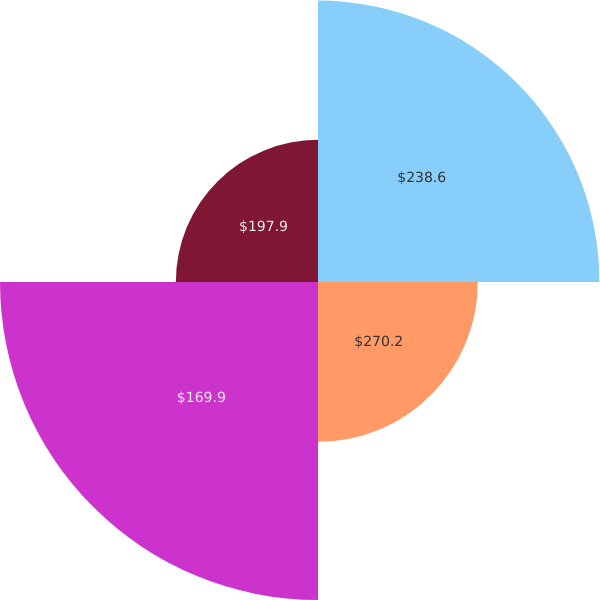Convert chart. <chart><loc_0><loc_0><loc_500><loc_500><pie_chart><fcel>$238.6<fcel>$270.2<fcel>$169.9<fcel>$197.9<nl><fcel>31.22%<fcel>17.73%<fcel>35.28%<fcel>15.77%<nl></chart> 